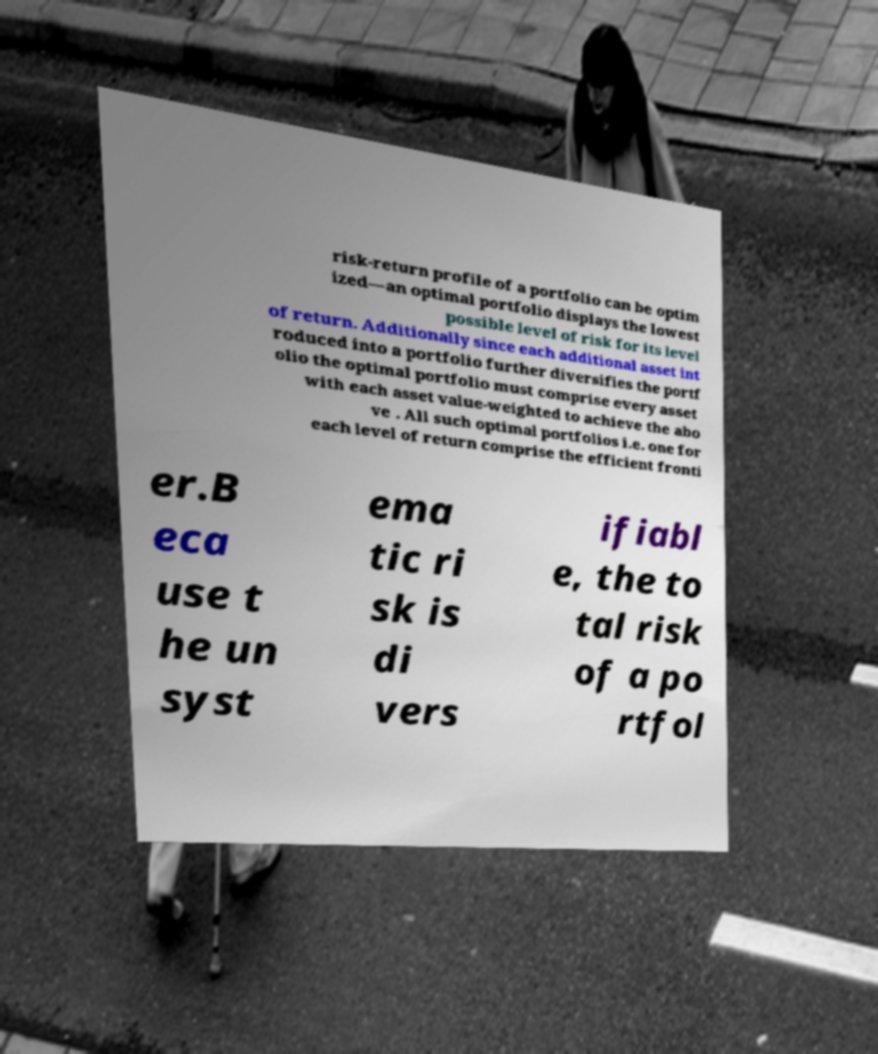Please read and relay the text visible in this image. What does it say? risk-return profile of a portfolio can be optim ized—an optimal portfolio displays the lowest possible level of risk for its level of return. Additionally since each additional asset int roduced into a portfolio further diversifies the portf olio the optimal portfolio must comprise every asset with each asset value-weighted to achieve the abo ve . All such optimal portfolios i.e. one for each level of return comprise the efficient fronti er.B eca use t he un syst ema tic ri sk is di vers ifiabl e, the to tal risk of a po rtfol 